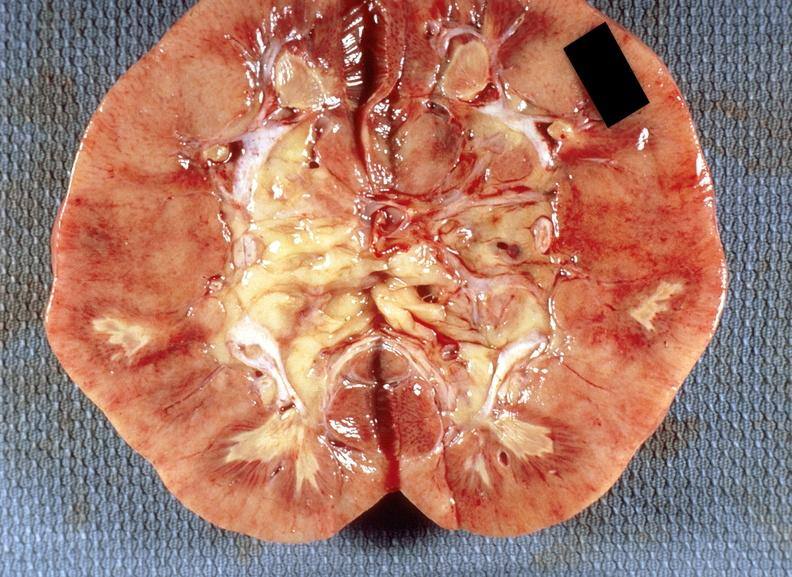where is this?
Answer the question using a single word or phrase. Urinary 